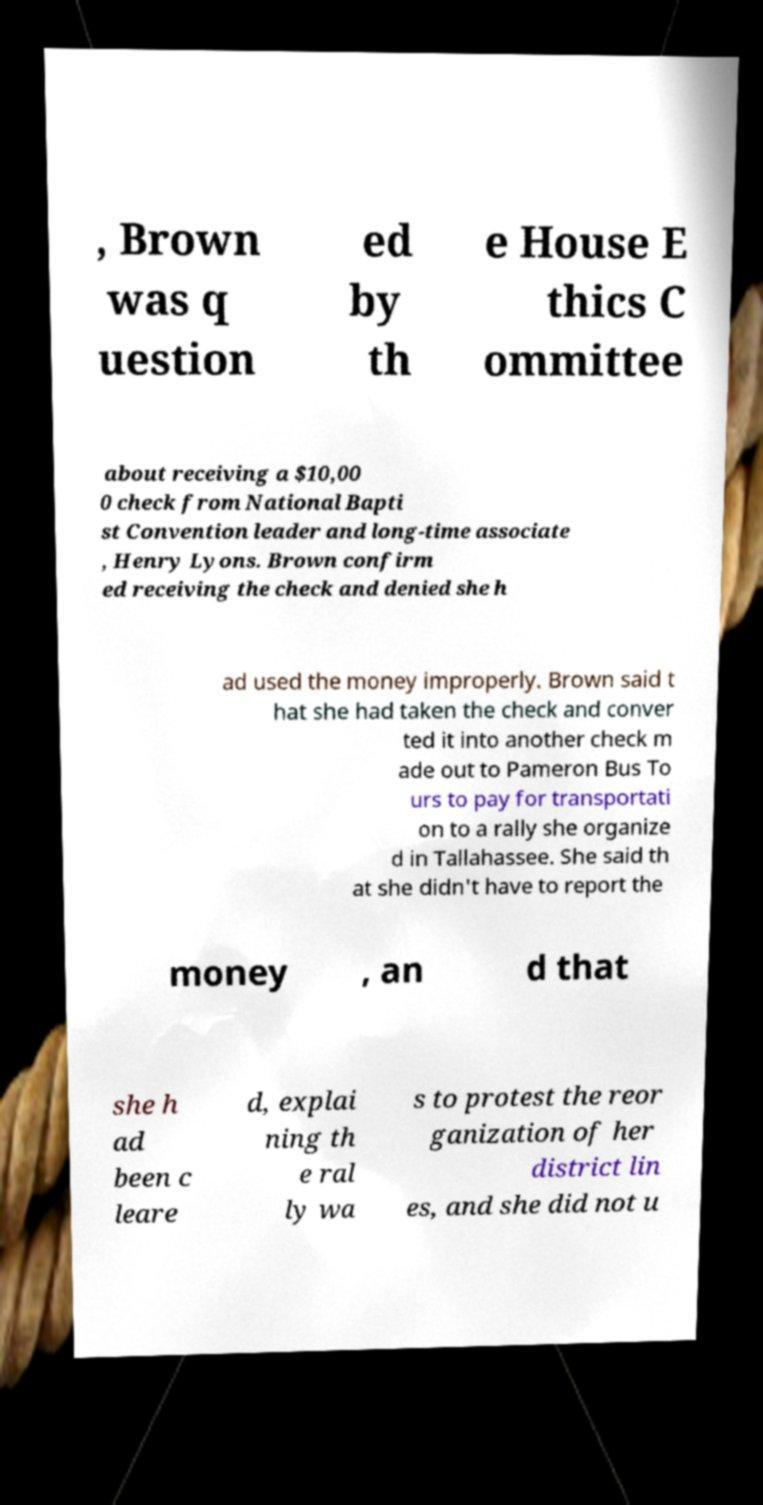Can you read and provide the text displayed in the image?This photo seems to have some interesting text. Can you extract and type it out for me? , Brown was q uestion ed by th e House E thics C ommittee about receiving a $10,00 0 check from National Bapti st Convention leader and long-time associate , Henry Lyons. Brown confirm ed receiving the check and denied she h ad used the money improperly. Brown said t hat she had taken the check and conver ted it into another check m ade out to Pameron Bus To urs to pay for transportati on to a rally she organize d in Tallahassee. She said th at she didn't have to report the money , an d that she h ad been c leare d, explai ning th e ral ly wa s to protest the reor ganization of her district lin es, and she did not u 